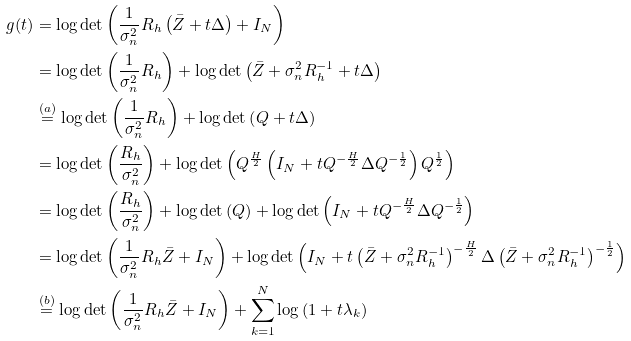Convert formula to latex. <formula><loc_0><loc_0><loc_500><loc_500>g ( t ) & = \log \det \left ( \frac { 1 } { \sigma _ { n } ^ { 2 } } R _ { h } \left ( \bar { Z } + t \Delta \right ) + I _ { N } \right ) \\ & = \log \det \left ( \frac { 1 } { \sigma _ { n } ^ { 2 } } R _ { h } \right ) + \log \det \left ( \bar { Z } + \sigma _ { n } ^ { 2 } R _ { h } ^ { - 1 } + t \Delta \right ) \\ & \stackrel { ( a ) } { = } \log \det \left ( \frac { 1 } { \sigma _ { n } ^ { 2 } } R _ { h } \right ) + \log \det \left ( Q + t \Delta \right ) \\ & = \log \det \left ( \frac { R _ { h } } { \sigma _ { n } ^ { 2 } } \right ) + \log \det \left ( Q ^ { \frac { H } { 2 } } \left ( I _ { N } + t Q ^ { - \frac { H } { 2 } } \Delta Q ^ { - \frac { 1 } { 2 } } \right ) Q ^ { \frac { 1 } { 2 } } \right ) \\ & = \log \det \left ( \frac { R _ { h } } { \sigma _ { n } ^ { 2 } } \right ) + \log \det \left ( Q \right ) + \log \det \left ( I _ { N } + t Q ^ { - \frac { H } { 2 } } \Delta Q ^ { - \frac { 1 } { 2 } } \right ) \\ & = \log \det \left ( \frac { 1 } { \sigma _ { n } ^ { 2 } } R _ { h } \bar { Z } + I _ { N } \right ) + \log \det \left ( I _ { N } + t \left ( \bar { Z } + \sigma _ { n } ^ { 2 } R _ { h } ^ { - 1 } \right ) ^ { - \frac { H } { 2 } } \Delta \left ( \bar { Z } + \sigma _ { n } ^ { 2 } R _ { h } ^ { - 1 } \right ) ^ { - \frac { 1 } { 2 } } \right ) \\ & \stackrel { ( b ) } { = } \log \det \left ( \frac { 1 } { \sigma _ { n } ^ { 2 } } R _ { h } \bar { Z } + I _ { N } \right ) + \sum _ { k = 1 } ^ { N } \log \left ( 1 + t \lambda _ { k } \right )</formula> 